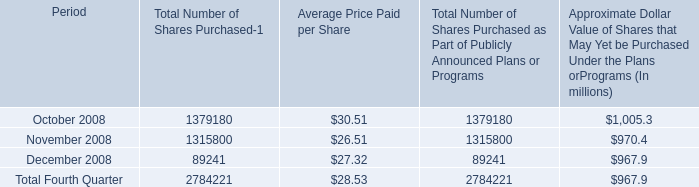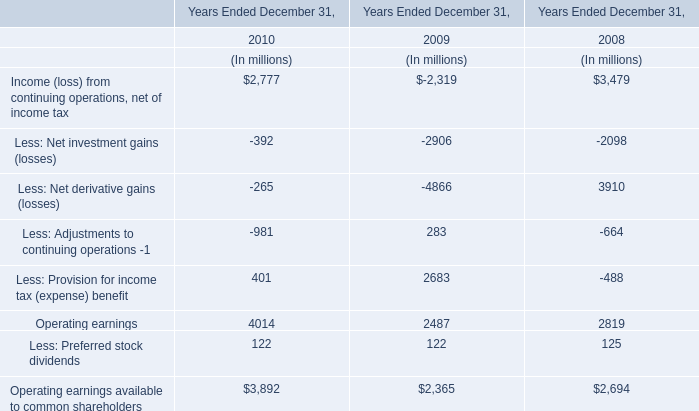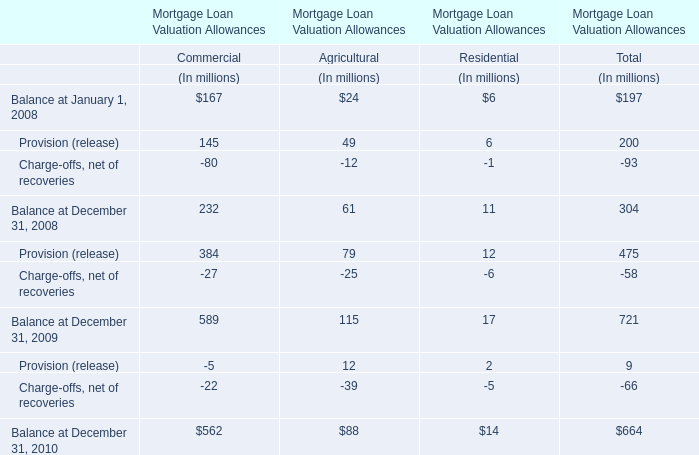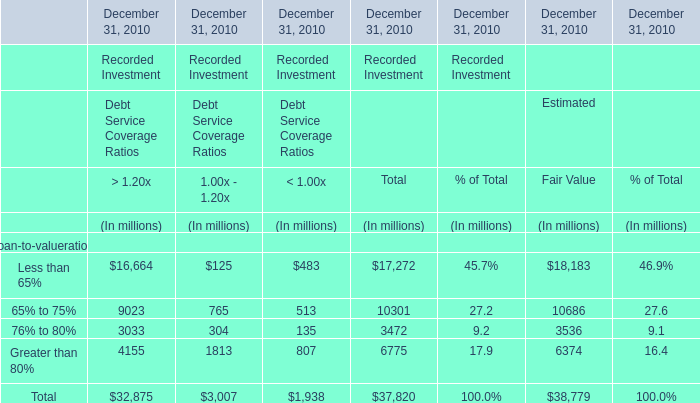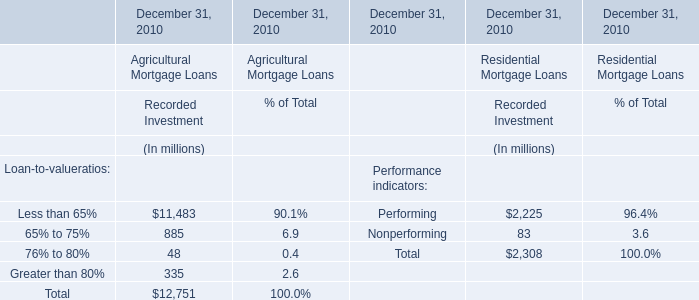What is the percentage of all elements that are positive to the total amount, in Estimated? 
Computations: ((((18183 + 10686) + 3536) + 6374) / 38779)
Answer: 1.0. 